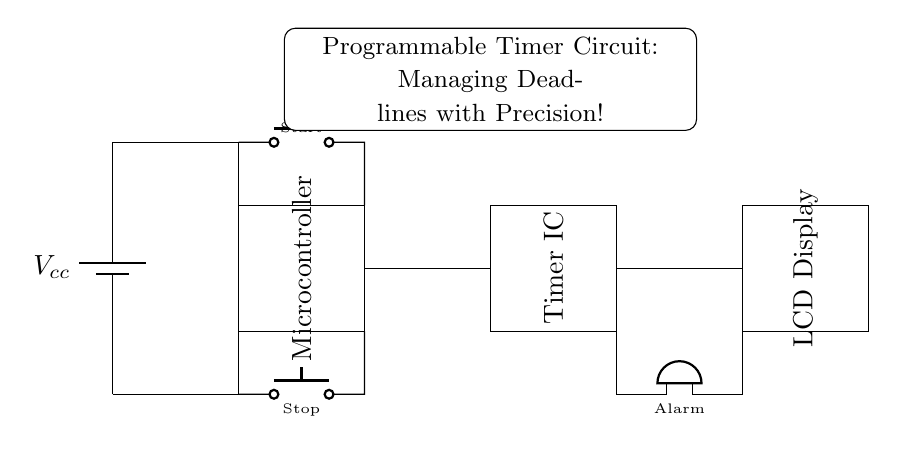What type of microcontroller is used in this circuit? The circuit diagram does not specify the exact type of microcontroller used, but it indicates that a microcontroller is present to manage the timer functions.
Answer: Microcontroller What is the purpose of the Timer IC? The Timer IC is used to create timing delay and control the operation of the programmable timer, allowing users to set specific work sessions and deadlines.
Answer: Timing What component is used to display information? An LCD Display is used to show the time remaining, settings, or status of the timer, providing a visual indication to the user.
Answer: LCD Display How many buttons are there in this circuit? There are two push buttons illustrated in the circuit diagram, one for starting the timer and one for stopping it.
Answer: Two What does the buzzer do in this circuit? The buzzer serves as an alarm to signal the end of the timer period, alerting the user when the set time has elapsed.
Answer: Alarm What is the voltage supply indicated for this circuit? The circuit designates Vcc as the power supply, but it does not specify the exact voltage value; it implies that a standard positive voltage is used.
Answer: Vcc How are the microcontroller and Timer IC connected? The microcontroller and Timer IC are connected through a wire, allowing the microcontroller to communicate timer settings and control signals to the Timer IC.
Answer: Wire 